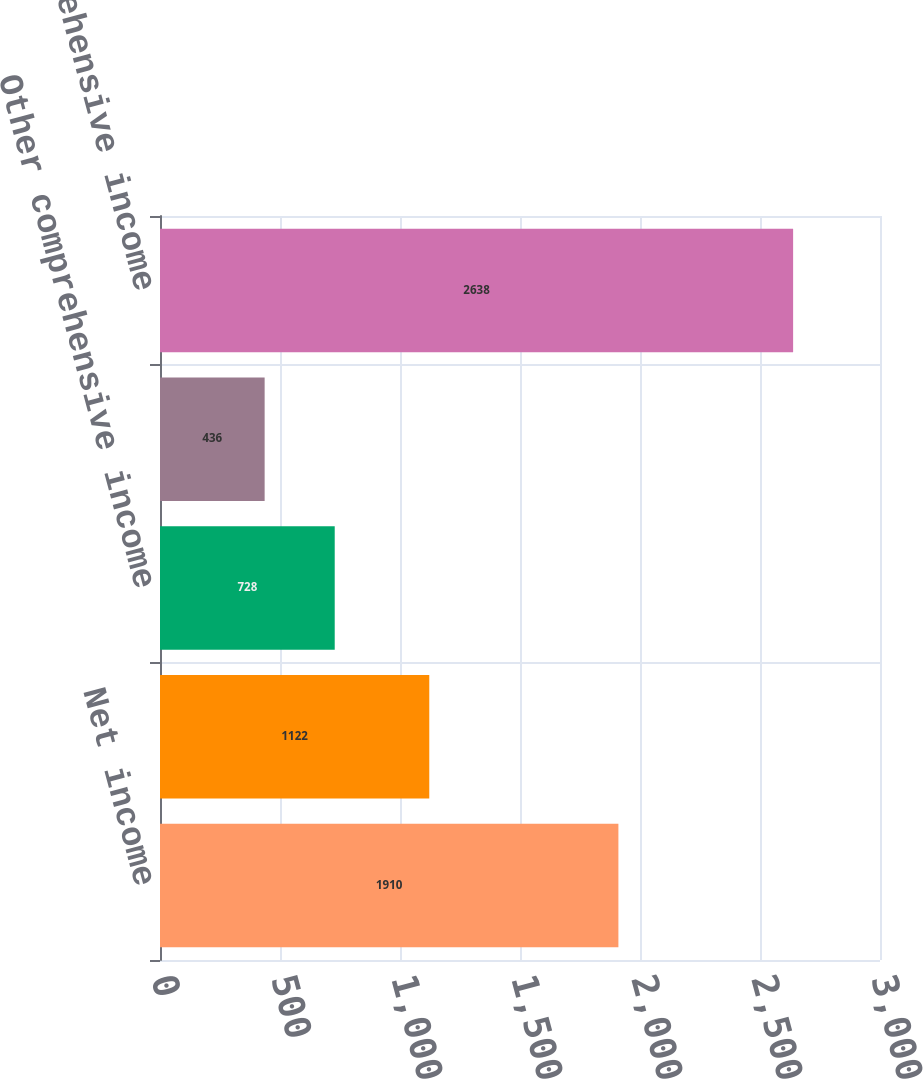Convert chart to OTSL. <chart><loc_0><loc_0><loc_500><loc_500><bar_chart><fcel>Net income<fcel>Pension and other<fcel>Other comprehensive income<fcel>Income tax benefit (expense)<fcel>Total comprehensive income<nl><fcel>1910<fcel>1122<fcel>728<fcel>436<fcel>2638<nl></chart> 